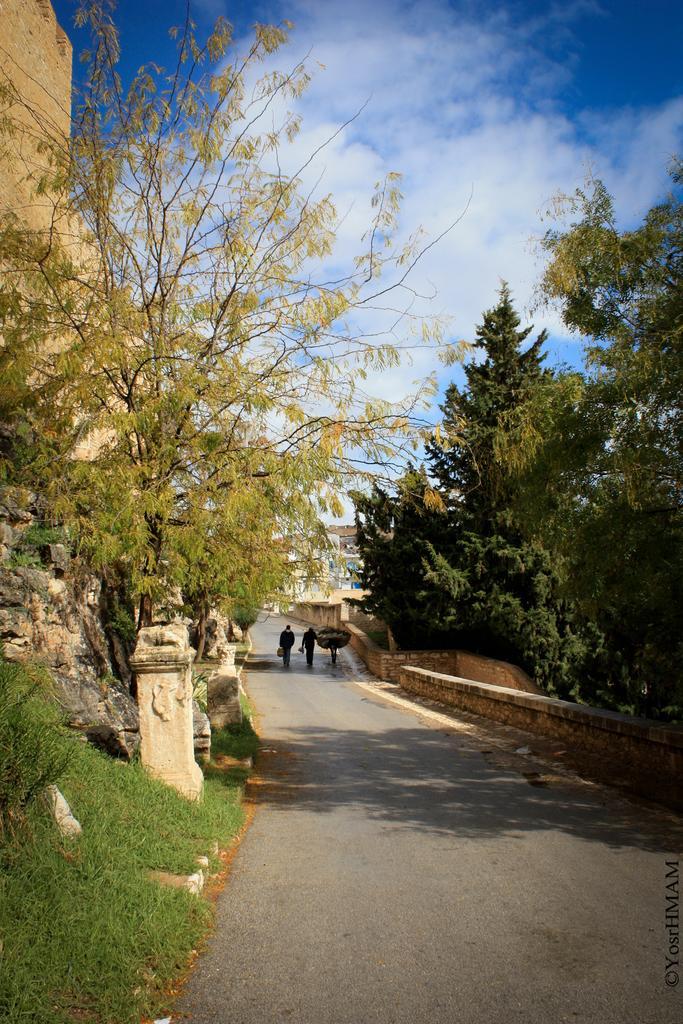Can you describe this image briefly? In this image we can see many trees, there is grass, there are a group of people walking on the road, the sky is cloudy. 